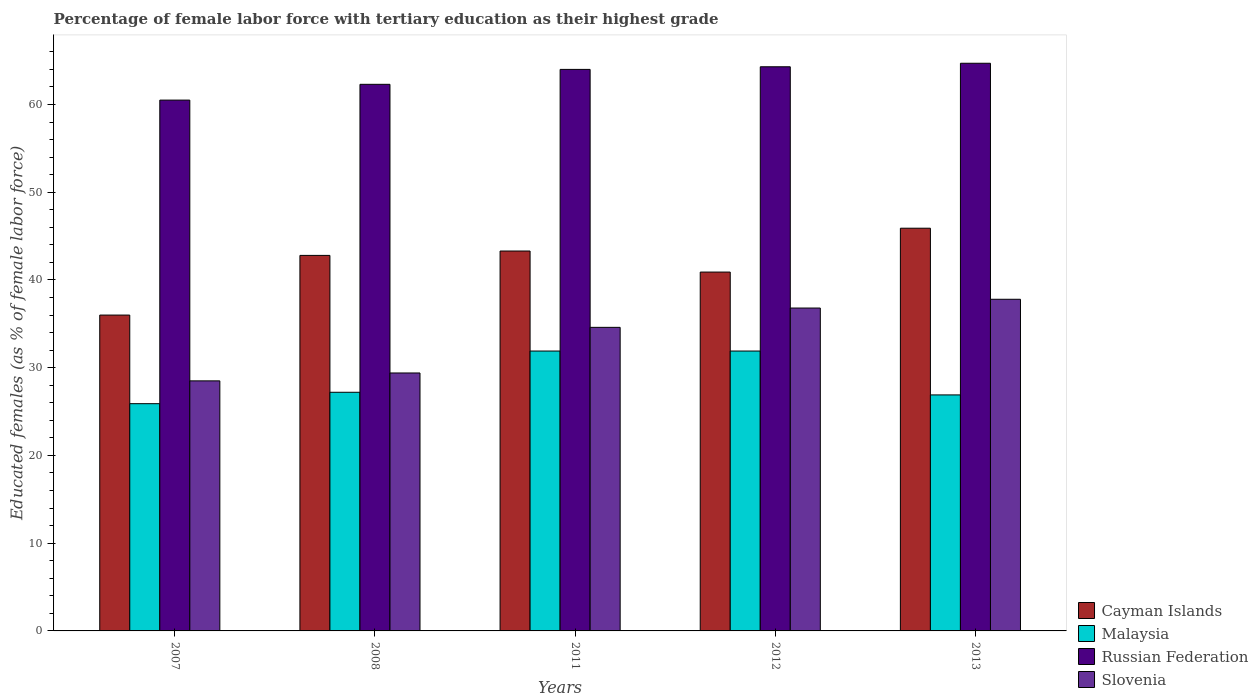How many different coloured bars are there?
Provide a succinct answer. 4. How many groups of bars are there?
Provide a succinct answer. 5. In how many cases, is the number of bars for a given year not equal to the number of legend labels?
Your answer should be very brief. 0. What is the percentage of female labor force with tertiary education in Cayman Islands in 2012?
Offer a terse response. 40.9. Across all years, what is the maximum percentage of female labor force with tertiary education in Russian Federation?
Your answer should be very brief. 64.7. In which year was the percentage of female labor force with tertiary education in Russian Federation minimum?
Your response must be concise. 2007. What is the total percentage of female labor force with tertiary education in Slovenia in the graph?
Provide a short and direct response. 167.1. What is the difference between the percentage of female labor force with tertiary education in Cayman Islands in 2011 and that in 2012?
Provide a short and direct response. 2.4. What is the difference between the percentage of female labor force with tertiary education in Russian Federation in 2012 and the percentage of female labor force with tertiary education in Slovenia in 2013?
Provide a succinct answer. 26.5. What is the average percentage of female labor force with tertiary education in Malaysia per year?
Keep it short and to the point. 28.76. In the year 2008, what is the difference between the percentage of female labor force with tertiary education in Malaysia and percentage of female labor force with tertiary education in Cayman Islands?
Give a very brief answer. -15.6. In how many years, is the percentage of female labor force with tertiary education in Russian Federation greater than 56 %?
Keep it short and to the point. 5. What is the ratio of the percentage of female labor force with tertiary education in Russian Federation in 2012 to that in 2013?
Offer a very short reply. 0.99. Is the percentage of female labor force with tertiary education in Cayman Islands in 2011 less than that in 2013?
Offer a terse response. Yes. Is the difference between the percentage of female labor force with tertiary education in Malaysia in 2007 and 2011 greater than the difference between the percentage of female labor force with tertiary education in Cayman Islands in 2007 and 2011?
Your answer should be compact. Yes. What is the difference between the highest and the lowest percentage of female labor force with tertiary education in Slovenia?
Give a very brief answer. 9.3. Is the sum of the percentage of female labor force with tertiary education in Cayman Islands in 2007 and 2012 greater than the maximum percentage of female labor force with tertiary education in Slovenia across all years?
Your response must be concise. Yes. What does the 2nd bar from the left in 2011 represents?
Your response must be concise. Malaysia. What does the 3rd bar from the right in 2013 represents?
Provide a short and direct response. Malaysia. Is it the case that in every year, the sum of the percentage of female labor force with tertiary education in Cayman Islands and percentage of female labor force with tertiary education in Slovenia is greater than the percentage of female labor force with tertiary education in Malaysia?
Offer a terse response. Yes. How many bars are there?
Give a very brief answer. 20. What is the difference between two consecutive major ticks on the Y-axis?
Give a very brief answer. 10. Are the values on the major ticks of Y-axis written in scientific E-notation?
Make the answer very short. No. Does the graph contain any zero values?
Your response must be concise. No. Where does the legend appear in the graph?
Keep it short and to the point. Bottom right. How many legend labels are there?
Offer a very short reply. 4. What is the title of the graph?
Your answer should be compact. Percentage of female labor force with tertiary education as their highest grade. Does "El Salvador" appear as one of the legend labels in the graph?
Your answer should be compact. No. What is the label or title of the Y-axis?
Your answer should be compact. Educated females (as % of female labor force). What is the Educated females (as % of female labor force) in Cayman Islands in 2007?
Offer a very short reply. 36. What is the Educated females (as % of female labor force) in Malaysia in 2007?
Ensure brevity in your answer.  25.9. What is the Educated females (as % of female labor force) in Russian Federation in 2007?
Your answer should be compact. 60.5. What is the Educated females (as % of female labor force) of Slovenia in 2007?
Make the answer very short. 28.5. What is the Educated females (as % of female labor force) in Cayman Islands in 2008?
Your response must be concise. 42.8. What is the Educated females (as % of female labor force) in Malaysia in 2008?
Provide a short and direct response. 27.2. What is the Educated females (as % of female labor force) in Russian Federation in 2008?
Ensure brevity in your answer.  62.3. What is the Educated females (as % of female labor force) of Slovenia in 2008?
Your answer should be very brief. 29.4. What is the Educated females (as % of female labor force) of Cayman Islands in 2011?
Keep it short and to the point. 43.3. What is the Educated females (as % of female labor force) in Malaysia in 2011?
Your answer should be very brief. 31.9. What is the Educated females (as % of female labor force) of Russian Federation in 2011?
Offer a terse response. 64. What is the Educated females (as % of female labor force) of Slovenia in 2011?
Offer a terse response. 34.6. What is the Educated females (as % of female labor force) of Cayman Islands in 2012?
Your answer should be very brief. 40.9. What is the Educated females (as % of female labor force) of Malaysia in 2012?
Your answer should be compact. 31.9. What is the Educated females (as % of female labor force) of Russian Federation in 2012?
Offer a very short reply. 64.3. What is the Educated females (as % of female labor force) of Slovenia in 2012?
Your answer should be very brief. 36.8. What is the Educated females (as % of female labor force) of Cayman Islands in 2013?
Keep it short and to the point. 45.9. What is the Educated females (as % of female labor force) in Malaysia in 2013?
Give a very brief answer. 26.9. What is the Educated females (as % of female labor force) in Russian Federation in 2013?
Make the answer very short. 64.7. What is the Educated females (as % of female labor force) in Slovenia in 2013?
Provide a short and direct response. 37.8. Across all years, what is the maximum Educated females (as % of female labor force) in Cayman Islands?
Give a very brief answer. 45.9. Across all years, what is the maximum Educated females (as % of female labor force) of Malaysia?
Keep it short and to the point. 31.9. Across all years, what is the maximum Educated females (as % of female labor force) in Russian Federation?
Your answer should be very brief. 64.7. Across all years, what is the maximum Educated females (as % of female labor force) in Slovenia?
Your response must be concise. 37.8. Across all years, what is the minimum Educated females (as % of female labor force) in Cayman Islands?
Provide a short and direct response. 36. Across all years, what is the minimum Educated females (as % of female labor force) of Malaysia?
Provide a short and direct response. 25.9. Across all years, what is the minimum Educated females (as % of female labor force) in Russian Federation?
Provide a short and direct response. 60.5. Across all years, what is the minimum Educated females (as % of female labor force) in Slovenia?
Offer a terse response. 28.5. What is the total Educated females (as % of female labor force) in Cayman Islands in the graph?
Offer a very short reply. 208.9. What is the total Educated females (as % of female labor force) of Malaysia in the graph?
Ensure brevity in your answer.  143.8. What is the total Educated females (as % of female labor force) in Russian Federation in the graph?
Offer a very short reply. 315.8. What is the total Educated females (as % of female labor force) of Slovenia in the graph?
Offer a very short reply. 167.1. What is the difference between the Educated females (as % of female labor force) of Cayman Islands in 2007 and that in 2008?
Offer a very short reply. -6.8. What is the difference between the Educated females (as % of female labor force) of Slovenia in 2007 and that in 2008?
Your answer should be very brief. -0.9. What is the difference between the Educated females (as % of female labor force) in Russian Federation in 2007 and that in 2011?
Provide a succinct answer. -3.5. What is the difference between the Educated females (as % of female labor force) of Slovenia in 2007 and that in 2012?
Offer a very short reply. -8.3. What is the difference between the Educated females (as % of female labor force) in Cayman Islands in 2007 and that in 2013?
Your answer should be compact. -9.9. What is the difference between the Educated females (as % of female labor force) in Slovenia in 2007 and that in 2013?
Keep it short and to the point. -9.3. What is the difference between the Educated females (as % of female labor force) of Cayman Islands in 2008 and that in 2011?
Keep it short and to the point. -0.5. What is the difference between the Educated females (as % of female labor force) of Malaysia in 2008 and that in 2011?
Your response must be concise. -4.7. What is the difference between the Educated females (as % of female labor force) in Russian Federation in 2008 and that in 2011?
Your response must be concise. -1.7. What is the difference between the Educated females (as % of female labor force) of Slovenia in 2008 and that in 2011?
Your answer should be very brief. -5.2. What is the difference between the Educated females (as % of female labor force) of Malaysia in 2008 and that in 2012?
Provide a short and direct response. -4.7. What is the difference between the Educated females (as % of female labor force) of Slovenia in 2008 and that in 2013?
Give a very brief answer. -8.4. What is the difference between the Educated females (as % of female labor force) in Russian Federation in 2011 and that in 2012?
Provide a short and direct response. -0.3. What is the difference between the Educated females (as % of female labor force) of Slovenia in 2011 and that in 2012?
Your response must be concise. -2.2. What is the difference between the Educated females (as % of female labor force) in Cayman Islands in 2011 and that in 2013?
Keep it short and to the point. -2.6. What is the difference between the Educated females (as % of female labor force) in Malaysia in 2011 and that in 2013?
Offer a very short reply. 5. What is the difference between the Educated females (as % of female labor force) in Slovenia in 2011 and that in 2013?
Make the answer very short. -3.2. What is the difference between the Educated females (as % of female labor force) of Malaysia in 2012 and that in 2013?
Your answer should be compact. 5. What is the difference between the Educated females (as % of female labor force) in Cayman Islands in 2007 and the Educated females (as % of female labor force) in Malaysia in 2008?
Give a very brief answer. 8.8. What is the difference between the Educated females (as % of female labor force) of Cayman Islands in 2007 and the Educated females (as % of female labor force) of Russian Federation in 2008?
Provide a succinct answer. -26.3. What is the difference between the Educated females (as % of female labor force) of Cayman Islands in 2007 and the Educated females (as % of female labor force) of Slovenia in 2008?
Your response must be concise. 6.6. What is the difference between the Educated females (as % of female labor force) of Malaysia in 2007 and the Educated females (as % of female labor force) of Russian Federation in 2008?
Your answer should be compact. -36.4. What is the difference between the Educated females (as % of female labor force) in Russian Federation in 2007 and the Educated females (as % of female labor force) in Slovenia in 2008?
Give a very brief answer. 31.1. What is the difference between the Educated females (as % of female labor force) in Cayman Islands in 2007 and the Educated females (as % of female labor force) in Russian Federation in 2011?
Your response must be concise. -28. What is the difference between the Educated females (as % of female labor force) of Cayman Islands in 2007 and the Educated females (as % of female labor force) of Slovenia in 2011?
Your answer should be very brief. 1.4. What is the difference between the Educated females (as % of female labor force) in Malaysia in 2007 and the Educated females (as % of female labor force) in Russian Federation in 2011?
Ensure brevity in your answer.  -38.1. What is the difference between the Educated females (as % of female labor force) in Russian Federation in 2007 and the Educated females (as % of female labor force) in Slovenia in 2011?
Provide a short and direct response. 25.9. What is the difference between the Educated females (as % of female labor force) in Cayman Islands in 2007 and the Educated females (as % of female labor force) in Malaysia in 2012?
Ensure brevity in your answer.  4.1. What is the difference between the Educated females (as % of female labor force) of Cayman Islands in 2007 and the Educated females (as % of female labor force) of Russian Federation in 2012?
Offer a very short reply. -28.3. What is the difference between the Educated females (as % of female labor force) of Cayman Islands in 2007 and the Educated females (as % of female labor force) of Slovenia in 2012?
Provide a succinct answer. -0.8. What is the difference between the Educated females (as % of female labor force) of Malaysia in 2007 and the Educated females (as % of female labor force) of Russian Federation in 2012?
Ensure brevity in your answer.  -38.4. What is the difference between the Educated females (as % of female labor force) of Malaysia in 2007 and the Educated females (as % of female labor force) of Slovenia in 2012?
Provide a short and direct response. -10.9. What is the difference between the Educated females (as % of female labor force) of Russian Federation in 2007 and the Educated females (as % of female labor force) of Slovenia in 2012?
Make the answer very short. 23.7. What is the difference between the Educated females (as % of female labor force) of Cayman Islands in 2007 and the Educated females (as % of female labor force) of Russian Federation in 2013?
Make the answer very short. -28.7. What is the difference between the Educated females (as % of female labor force) in Cayman Islands in 2007 and the Educated females (as % of female labor force) in Slovenia in 2013?
Make the answer very short. -1.8. What is the difference between the Educated females (as % of female labor force) in Malaysia in 2007 and the Educated females (as % of female labor force) in Russian Federation in 2013?
Keep it short and to the point. -38.8. What is the difference between the Educated females (as % of female labor force) in Russian Federation in 2007 and the Educated females (as % of female labor force) in Slovenia in 2013?
Ensure brevity in your answer.  22.7. What is the difference between the Educated females (as % of female labor force) of Cayman Islands in 2008 and the Educated females (as % of female labor force) of Russian Federation in 2011?
Provide a succinct answer. -21.2. What is the difference between the Educated females (as % of female labor force) in Cayman Islands in 2008 and the Educated females (as % of female labor force) in Slovenia in 2011?
Provide a succinct answer. 8.2. What is the difference between the Educated females (as % of female labor force) in Malaysia in 2008 and the Educated females (as % of female labor force) in Russian Federation in 2011?
Offer a terse response. -36.8. What is the difference between the Educated females (as % of female labor force) of Malaysia in 2008 and the Educated females (as % of female labor force) of Slovenia in 2011?
Your response must be concise. -7.4. What is the difference between the Educated females (as % of female labor force) in Russian Federation in 2008 and the Educated females (as % of female labor force) in Slovenia in 2011?
Your response must be concise. 27.7. What is the difference between the Educated females (as % of female labor force) of Cayman Islands in 2008 and the Educated females (as % of female labor force) of Russian Federation in 2012?
Give a very brief answer. -21.5. What is the difference between the Educated females (as % of female labor force) in Malaysia in 2008 and the Educated females (as % of female labor force) in Russian Federation in 2012?
Keep it short and to the point. -37.1. What is the difference between the Educated females (as % of female labor force) in Russian Federation in 2008 and the Educated females (as % of female labor force) in Slovenia in 2012?
Make the answer very short. 25.5. What is the difference between the Educated females (as % of female labor force) of Cayman Islands in 2008 and the Educated females (as % of female labor force) of Russian Federation in 2013?
Provide a short and direct response. -21.9. What is the difference between the Educated females (as % of female labor force) in Malaysia in 2008 and the Educated females (as % of female labor force) in Russian Federation in 2013?
Give a very brief answer. -37.5. What is the difference between the Educated females (as % of female labor force) in Malaysia in 2008 and the Educated females (as % of female labor force) in Slovenia in 2013?
Your answer should be compact. -10.6. What is the difference between the Educated females (as % of female labor force) of Cayman Islands in 2011 and the Educated females (as % of female labor force) of Malaysia in 2012?
Give a very brief answer. 11.4. What is the difference between the Educated females (as % of female labor force) of Cayman Islands in 2011 and the Educated females (as % of female labor force) of Slovenia in 2012?
Your answer should be very brief. 6.5. What is the difference between the Educated females (as % of female labor force) in Malaysia in 2011 and the Educated females (as % of female labor force) in Russian Federation in 2012?
Keep it short and to the point. -32.4. What is the difference between the Educated females (as % of female labor force) of Malaysia in 2011 and the Educated females (as % of female labor force) of Slovenia in 2012?
Make the answer very short. -4.9. What is the difference between the Educated females (as % of female labor force) of Russian Federation in 2011 and the Educated females (as % of female labor force) of Slovenia in 2012?
Provide a succinct answer. 27.2. What is the difference between the Educated females (as % of female labor force) of Cayman Islands in 2011 and the Educated females (as % of female labor force) of Malaysia in 2013?
Your answer should be very brief. 16.4. What is the difference between the Educated females (as % of female labor force) of Cayman Islands in 2011 and the Educated females (as % of female labor force) of Russian Federation in 2013?
Ensure brevity in your answer.  -21.4. What is the difference between the Educated females (as % of female labor force) of Malaysia in 2011 and the Educated females (as % of female labor force) of Russian Federation in 2013?
Provide a short and direct response. -32.8. What is the difference between the Educated females (as % of female labor force) in Russian Federation in 2011 and the Educated females (as % of female labor force) in Slovenia in 2013?
Offer a very short reply. 26.2. What is the difference between the Educated females (as % of female labor force) in Cayman Islands in 2012 and the Educated females (as % of female labor force) in Russian Federation in 2013?
Offer a very short reply. -23.8. What is the difference between the Educated females (as % of female labor force) in Malaysia in 2012 and the Educated females (as % of female labor force) in Russian Federation in 2013?
Offer a terse response. -32.8. What is the average Educated females (as % of female labor force) in Cayman Islands per year?
Offer a very short reply. 41.78. What is the average Educated females (as % of female labor force) of Malaysia per year?
Your response must be concise. 28.76. What is the average Educated females (as % of female labor force) of Russian Federation per year?
Provide a succinct answer. 63.16. What is the average Educated females (as % of female labor force) in Slovenia per year?
Provide a short and direct response. 33.42. In the year 2007, what is the difference between the Educated females (as % of female labor force) of Cayman Islands and Educated females (as % of female labor force) of Russian Federation?
Keep it short and to the point. -24.5. In the year 2007, what is the difference between the Educated females (as % of female labor force) in Malaysia and Educated females (as % of female labor force) in Russian Federation?
Your answer should be compact. -34.6. In the year 2007, what is the difference between the Educated females (as % of female labor force) of Russian Federation and Educated females (as % of female labor force) of Slovenia?
Ensure brevity in your answer.  32. In the year 2008, what is the difference between the Educated females (as % of female labor force) of Cayman Islands and Educated females (as % of female labor force) of Russian Federation?
Give a very brief answer. -19.5. In the year 2008, what is the difference between the Educated females (as % of female labor force) in Cayman Islands and Educated females (as % of female labor force) in Slovenia?
Give a very brief answer. 13.4. In the year 2008, what is the difference between the Educated females (as % of female labor force) of Malaysia and Educated females (as % of female labor force) of Russian Federation?
Offer a very short reply. -35.1. In the year 2008, what is the difference between the Educated females (as % of female labor force) of Malaysia and Educated females (as % of female labor force) of Slovenia?
Provide a short and direct response. -2.2. In the year 2008, what is the difference between the Educated females (as % of female labor force) in Russian Federation and Educated females (as % of female labor force) in Slovenia?
Your response must be concise. 32.9. In the year 2011, what is the difference between the Educated females (as % of female labor force) of Cayman Islands and Educated females (as % of female labor force) of Russian Federation?
Your response must be concise. -20.7. In the year 2011, what is the difference between the Educated females (as % of female labor force) in Cayman Islands and Educated females (as % of female labor force) in Slovenia?
Your response must be concise. 8.7. In the year 2011, what is the difference between the Educated females (as % of female labor force) in Malaysia and Educated females (as % of female labor force) in Russian Federation?
Provide a short and direct response. -32.1. In the year 2011, what is the difference between the Educated females (as % of female labor force) in Russian Federation and Educated females (as % of female labor force) in Slovenia?
Your answer should be compact. 29.4. In the year 2012, what is the difference between the Educated females (as % of female labor force) of Cayman Islands and Educated females (as % of female labor force) of Malaysia?
Ensure brevity in your answer.  9. In the year 2012, what is the difference between the Educated females (as % of female labor force) of Cayman Islands and Educated females (as % of female labor force) of Russian Federation?
Your answer should be very brief. -23.4. In the year 2012, what is the difference between the Educated females (as % of female labor force) of Malaysia and Educated females (as % of female labor force) of Russian Federation?
Your answer should be compact. -32.4. In the year 2012, what is the difference between the Educated females (as % of female labor force) in Russian Federation and Educated females (as % of female labor force) in Slovenia?
Offer a terse response. 27.5. In the year 2013, what is the difference between the Educated females (as % of female labor force) of Cayman Islands and Educated females (as % of female labor force) of Russian Federation?
Keep it short and to the point. -18.8. In the year 2013, what is the difference between the Educated females (as % of female labor force) of Malaysia and Educated females (as % of female labor force) of Russian Federation?
Offer a very short reply. -37.8. In the year 2013, what is the difference between the Educated females (as % of female labor force) of Russian Federation and Educated females (as % of female labor force) of Slovenia?
Your response must be concise. 26.9. What is the ratio of the Educated females (as % of female labor force) of Cayman Islands in 2007 to that in 2008?
Make the answer very short. 0.84. What is the ratio of the Educated females (as % of female labor force) in Malaysia in 2007 to that in 2008?
Offer a very short reply. 0.95. What is the ratio of the Educated females (as % of female labor force) of Russian Federation in 2007 to that in 2008?
Offer a very short reply. 0.97. What is the ratio of the Educated females (as % of female labor force) of Slovenia in 2007 to that in 2008?
Give a very brief answer. 0.97. What is the ratio of the Educated females (as % of female labor force) in Cayman Islands in 2007 to that in 2011?
Your answer should be very brief. 0.83. What is the ratio of the Educated females (as % of female labor force) of Malaysia in 2007 to that in 2011?
Your answer should be compact. 0.81. What is the ratio of the Educated females (as % of female labor force) in Russian Federation in 2007 to that in 2011?
Your answer should be very brief. 0.95. What is the ratio of the Educated females (as % of female labor force) of Slovenia in 2007 to that in 2011?
Ensure brevity in your answer.  0.82. What is the ratio of the Educated females (as % of female labor force) of Cayman Islands in 2007 to that in 2012?
Give a very brief answer. 0.88. What is the ratio of the Educated females (as % of female labor force) of Malaysia in 2007 to that in 2012?
Give a very brief answer. 0.81. What is the ratio of the Educated females (as % of female labor force) of Russian Federation in 2007 to that in 2012?
Make the answer very short. 0.94. What is the ratio of the Educated females (as % of female labor force) of Slovenia in 2007 to that in 2012?
Your answer should be compact. 0.77. What is the ratio of the Educated females (as % of female labor force) of Cayman Islands in 2007 to that in 2013?
Ensure brevity in your answer.  0.78. What is the ratio of the Educated females (as % of female labor force) in Malaysia in 2007 to that in 2013?
Offer a very short reply. 0.96. What is the ratio of the Educated females (as % of female labor force) of Russian Federation in 2007 to that in 2013?
Keep it short and to the point. 0.94. What is the ratio of the Educated females (as % of female labor force) of Slovenia in 2007 to that in 2013?
Offer a very short reply. 0.75. What is the ratio of the Educated females (as % of female labor force) in Cayman Islands in 2008 to that in 2011?
Keep it short and to the point. 0.99. What is the ratio of the Educated females (as % of female labor force) in Malaysia in 2008 to that in 2011?
Your response must be concise. 0.85. What is the ratio of the Educated females (as % of female labor force) in Russian Federation in 2008 to that in 2011?
Your answer should be compact. 0.97. What is the ratio of the Educated females (as % of female labor force) of Slovenia in 2008 to that in 2011?
Offer a very short reply. 0.85. What is the ratio of the Educated females (as % of female labor force) in Cayman Islands in 2008 to that in 2012?
Give a very brief answer. 1.05. What is the ratio of the Educated females (as % of female labor force) in Malaysia in 2008 to that in 2012?
Your answer should be very brief. 0.85. What is the ratio of the Educated females (as % of female labor force) of Russian Federation in 2008 to that in 2012?
Provide a succinct answer. 0.97. What is the ratio of the Educated females (as % of female labor force) in Slovenia in 2008 to that in 2012?
Offer a terse response. 0.8. What is the ratio of the Educated females (as % of female labor force) of Cayman Islands in 2008 to that in 2013?
Ensure brevity in your answer.  0.93. What is the ratio of the Educated females (as % of female labor force) in Malaysia in 2008 to that in 2013?
Your answer should be compact. 1.01. What is the ratio of the Educated females (as % of female labor force) in Russian Federation in 2008 to that in 2013?
Provide a short and direct response. 0.96. What is the ratio of the Educated females (as % of female labor force) of Slovenia in 2008 to that in 2013?
Offer a terse response. 0.78. What is the ratio of the Educated females (as % of female labor force) in Cayman Islands in 2011 to that in 2012?
Offer a terse response. 1.06. What is the ratio of the Educated females (as % of female labor force) in Slovenia in 2011 to that in 2012?
Provide a short and direct response. 0.94. What is the ratio of the Educated females (as % of female labor force) in Cayman Islands in 2011 to that in 2013?
Provide a succinct answer. 0.94. What is the ratio of the Educated females (as % of female labor force) in Malaysia in 2011 to that in 2013?
Provide a succinct answer. 1.19. What is the ratio of the Educated females (as % of female labor force) in Russian Federation in 2011 to that in 2013?
Keep it short and to the point. 0.99. What is the ratio of the Educated females (as % of female labor force) in Slovenia in 2011 to that in 2013?
Your response must be concise. 0.92. What is the ratio of the Educated females (as % of female labor force) of Cayman Islands in 2012 to that in 2013?
Provide a short and direct response. 0.89. What is the ratio of the Educated females (as % of female labor force) in Malaysia in 2012 to that in 2013?
Provide a succinct answer. 1.19. What is the ratio of the Educated females (as % of female labor force) in Russian Federation in 2012 to that in 2013?
Provide a succinct answer. 0.99. What is the ratio of the Educated females (as % of female labor force) in Slovenia in 2012 to that in 2013?
Give a very brief answer. 0.97. What is the difference between the highest and the second highest Educated females (as % of female labor force) in Malaysia?
Offer a terse response. 0. What is the difference between the highest and the second highest Educated females (as % of female labor force) of Russian Federation?
Offer a terse response. 0.4. What is the difference between the highest and the second highest Educated females (as % of female labor force) in Slovenia?
Your answer should be compact. 1. 